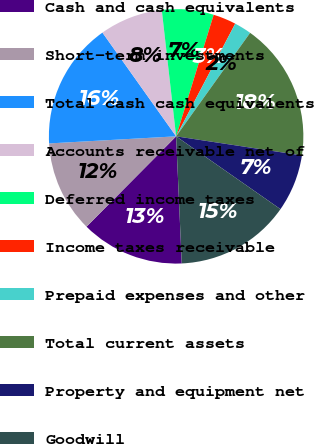<chart> <loc_0><loc_0><loc_500><loc_500><pie_chart><fcel>Cash and cash equivalents<fcel>Short-term investments<fcel>Total cash cash equivalents<fcel>Accounts receivable net of<fcel>Deferred income taxes<fcel>Income taxes receivable<fcel>Prepaid expenses and other<fcel>Total current assets<fcel>Property and equipment net<fcel>Goodwill<nl><fcel>13.14%<fcel>11.68%<fcel>16.06%<fcel>8.03%<fcel>6.57%<fcel>2.92%<fcel>2.19%<fcel>17.52%<fcel>7.3%<fcel>14.6%<nl></chart> 